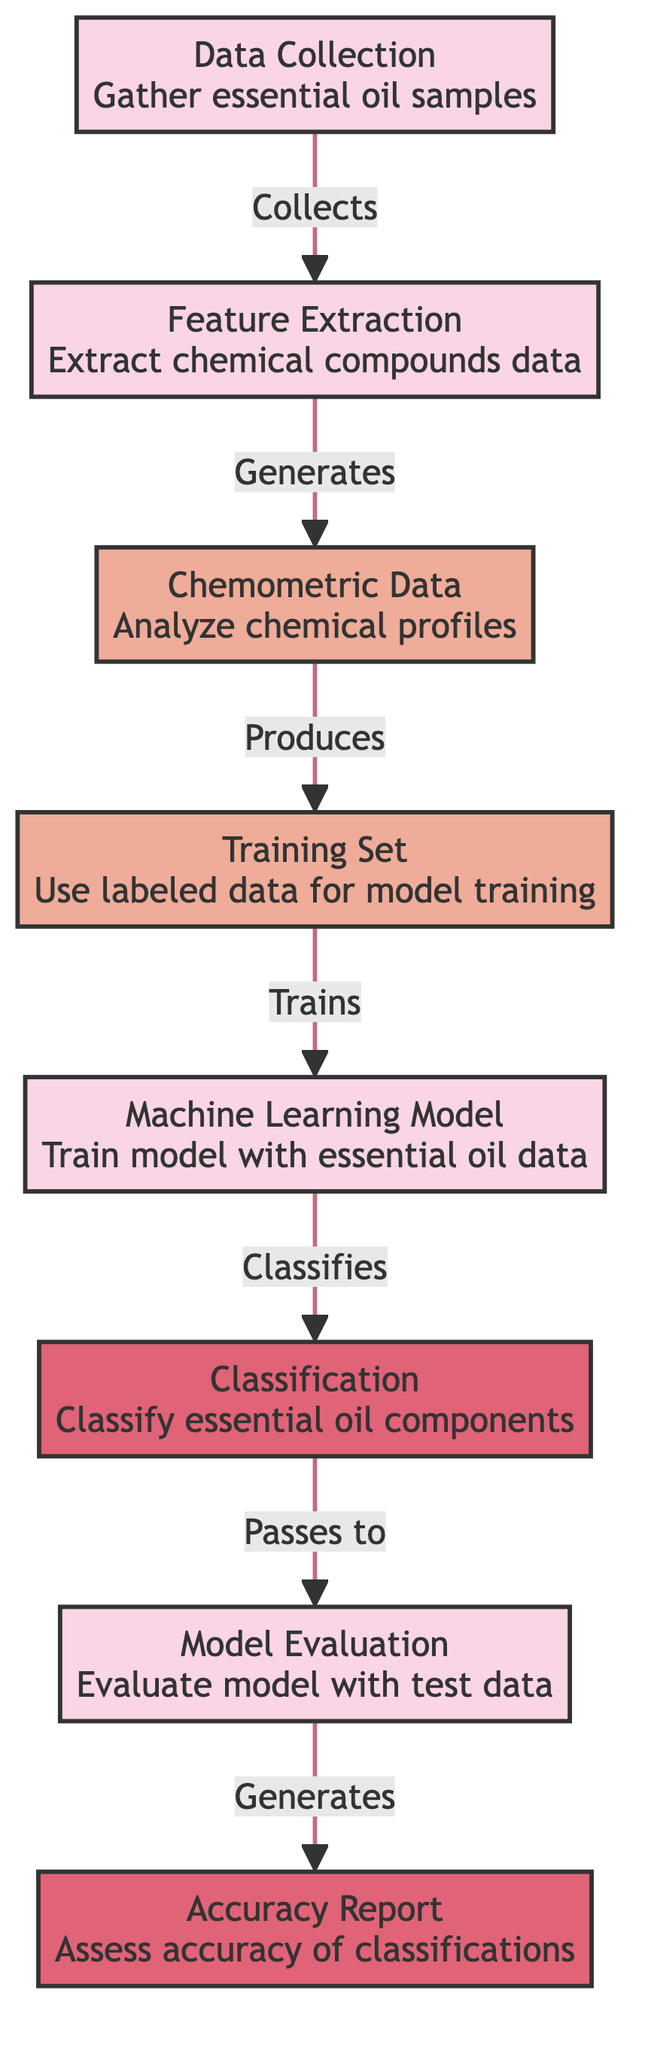What is the first node in the diagram? The first node in the diagram is "Data Collection" which initiates the process of gathering essential oil samples.
Answer: Data Collection How many nodes are in the diagram? By counting the distinct sections in the diagram, there are a total of seven nodes representing different steps in the machine learning process.
Answer: Seven What is the output of the last node? The last node in the diagram is "Accuracy Report," which assesses the accuracy of the classifications made by the model.
Answer: Accuracy Report Which node is responsible for generating the training set? The "Chemometric Data" node produces the "Training Set" using analyzed chemical profiles from the essential oils.
Answer: Training Set What is the relationship between the "Machine Learning Model" and the "Classification"? The arrow indicates that the "Machine Learning Model" is trained to classify essential oil components, establishing a direct relationship between these two nodes.
Answer: Classifies What step comes after the evaluation node? After the "Evaluation" node, the next step is generating the "Accuracy Report," which summarizes the outcomes of the evaluation process.
Answer: Accuracy Report Which two nodes are connected directly by an edge? The "Feature Extraction" and "Chemometric Data" nodes are directly connected, signifying the flow of data from extraction to analysis.
Answer: Chemometric Data How does the "Data Collection" node contribute to the process? The "Data Collection" node gathers essential oil samples, which is crucial for the subsequent steps in the machine learning classification process.
Answer: Gathers samples What type of data does the "Training Set" use? The "Training Set" uses labeled data to train the machine learning model, enabling it to classify the essential oil components accurately.
Answer: Labeled data 